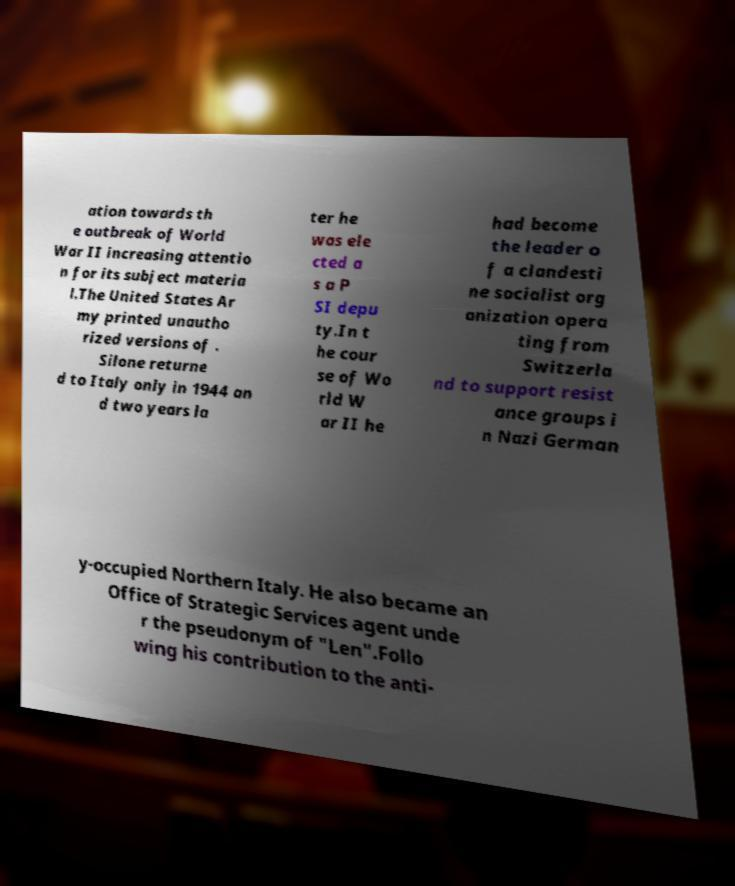What messages or text are displayed in this image? I need them in a readable, typed format. ation towards th e outbreak of World War II increasing attentio n for its subject materia l.The United States Ar my printed unautho rized versions of . Silone returne d to Italy only in 1944 an d two years la ter he was ele cted a s a P SI depu ty.In t he cour se of Wo rld W ar II he had become the leader o f a clandesti ne socialist org anization opera ting from Switzerla nd to support resist ance groups i n Nazi German y-occupied Northern Italy. He also became an Office of Strategic Services agent unde r the pseudonym of "Len".Follo wing his contribution to the anti- 